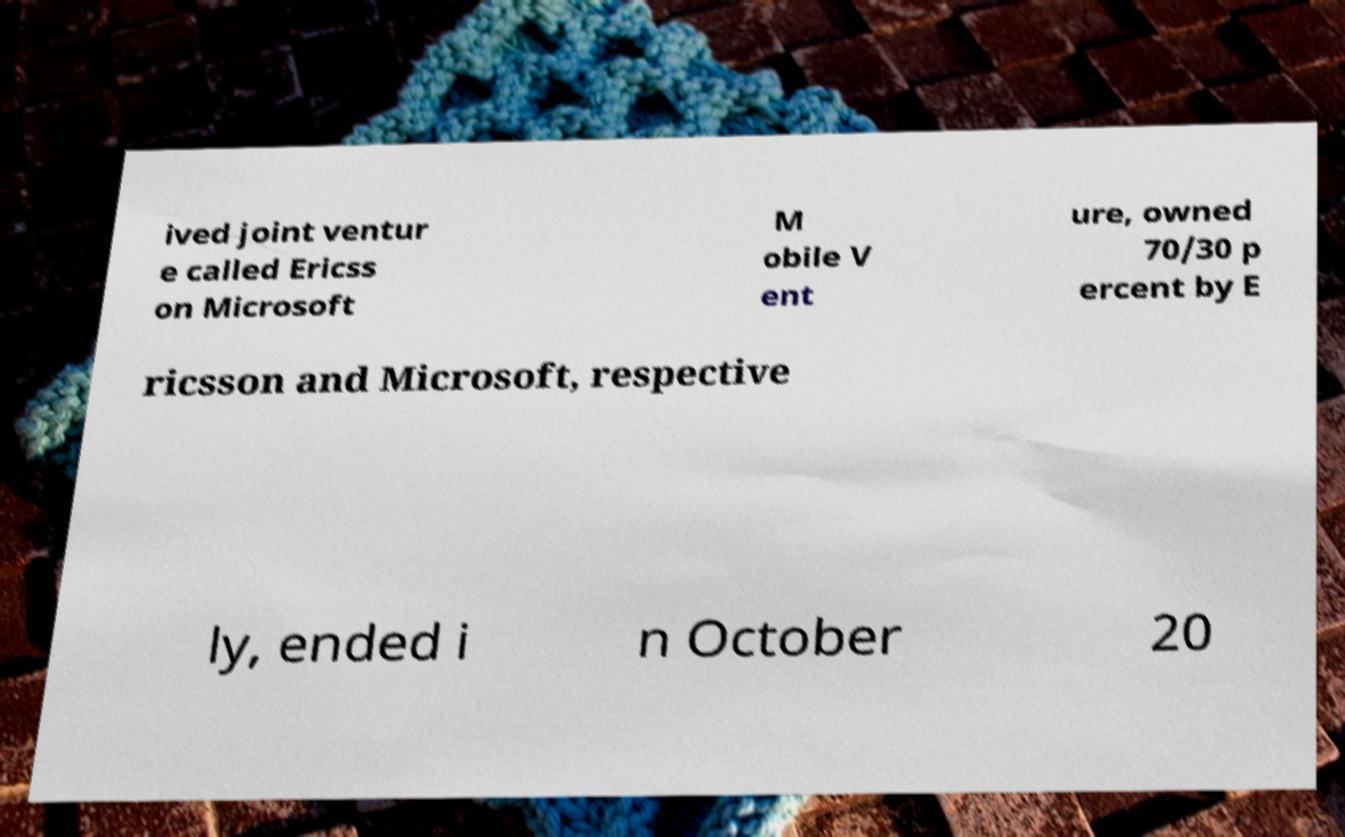For documentation purposes, I need the text within this image transcribed. Could you provide that? ived joint ventur e called Ericss on Microsoft M obile V ent ure, owned 70/30 p ercent by E ricsson and Microsoft, respective ly, ended i n October 20 